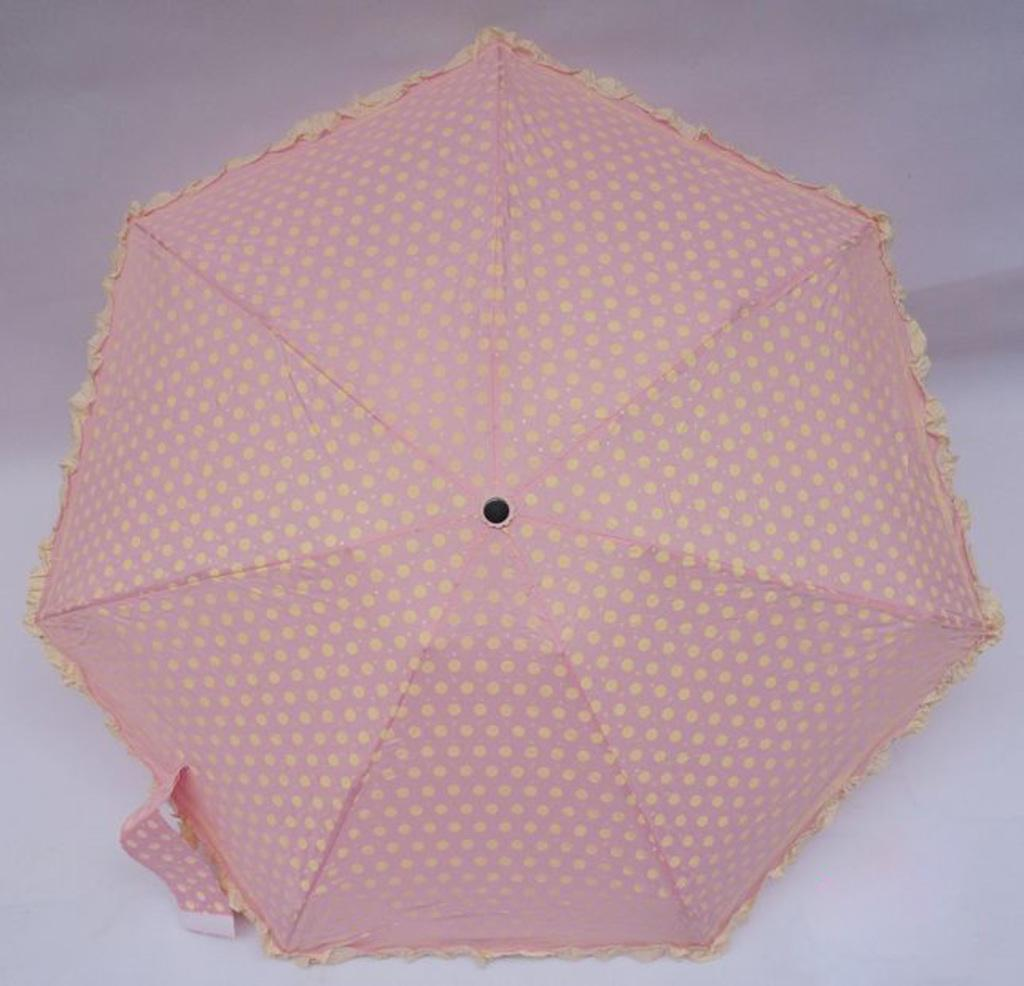What object can be seen in the image? There is an umbrella in the image. What is the color of the umbrella? The umbrella is pink in color. What can be seen in the background of the image? The background of the image is white. How does the umbrella contribute to the account balance in the image? The umbrella does not contribute to an account balance in the image, as it is an object and not related to financial transactions. 